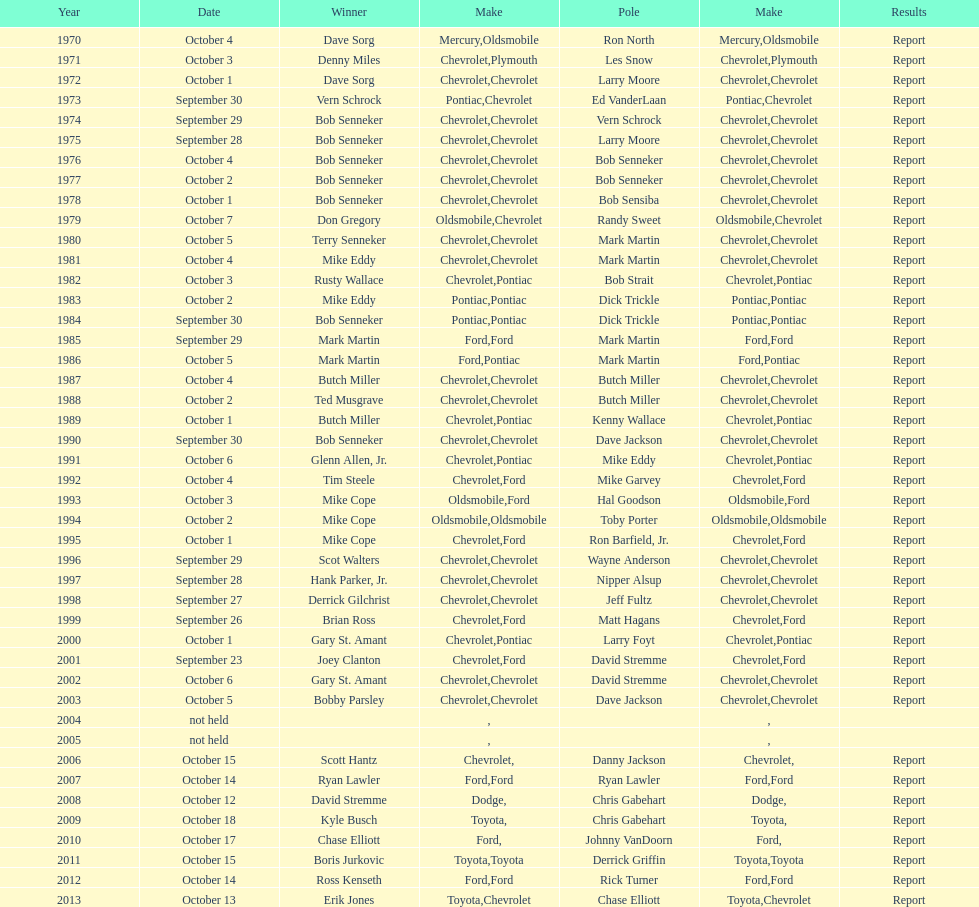Who among the list possesses the most consecutive triumphs? Bob Senneker. 